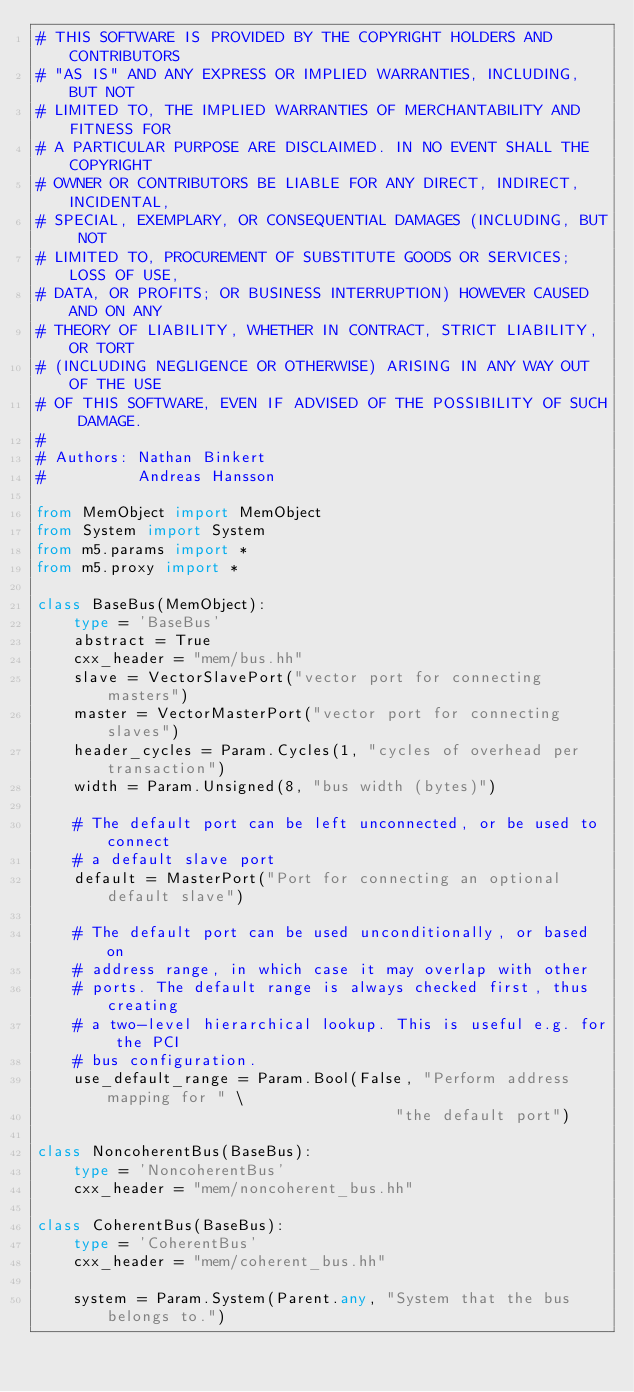Convert code to text. <code><loc_0><loc_0><loc_500><loc_500><_Python_># THIS SOFTWARE IS PROVIDED BY THE COPYRIGHT HOLDERS AND CONTRIBUTORS
# "AS IS" AND ANY EXPRESS OR IMPLIED WARRANTIES, INCLUDING, BUT NOT
# LIMITED TO, THE IMPLIED WARRANTIES OF MERCHANTABILITY AND FITNESS FOR
# A PARTICULAR PURPOSE ARE DISCLAIMED. IN NO EVENT SHALL THE COPYRIGHT
# OWNER OR CONTRIBUTORS BE LIABLE FOR ANY DIRECT, INDIRECT, INCIDENTAL,
# SPECIAL, EXEMPLARY, OR CONSEQUENTIAL DAMAGES (INCLUDING, BUT NOT
# LIMITED TO, PROCUREMENT OF SUBSTITUTE GOODS OR SERVICES; LOSS OF USE,
# DATA, OR PROFITS; OR BUSINESS INTERRUPTION) HOWEVER CAUSED AND ON ANY
# THEORY OF LIABILITY, WHETHER IN CONTRACT, STRICT LIABILITY, OR TORT
# (INCLUDING NEGLIGENCE OR OTHERWISE) ARISING IN ANY WAY OUT OF THE USE
# OF THIS SOFTWARE, EVEN IF ADVISED OF THE POSSIBILITY OF SUCH DAMAGE.
#
# Authors: Nathan Binkert
#          Andreas Hansson

from MemObject import MemObject
from System import System
from m5.params import *
from m5.proxy import *

class BaseBus(MemObject):
    type = 'BaseBus'
    abstract = True
    cxx_header = "mem/bus.hh"
    slave = VectorSlavePort("vector port for connecting masters")
    master = VectorMasterPort("vector port for connecting slaves")
    header_cycles = Param.Cycles(1, "cycles of overhead per transaction")
    width = Param.Unsigned(8, "bus width (bytes)")

    # The default port can be left unconnected, or be used to connect
    # a default slave port
    default = MasterPort("Port for connecting an optional default slave")

    # The default port can be used unconditionally, or based on
    # address range, in which case it may overlap with other
    # ports. The default range is always checked first, thus creating
    # a two-level hierarchical lookup. This is useful e.g. for the PCI
    # bus configuration.
    use_default_range = Param.Bool(False, "Perform address mapping for " \
                                       "the default port")

class NoncoherentBus(BaseBus):
    type = 'NoncoherentBus'
    cxx_header = "mem/noncoherent_bus.hh"

class CoherentBus(BaseBus):
    type = 'CoherentBus'
    cxx_header = "mem/coherent_bus.hh"

    system = Param.System(Parent.any, "System that the bus belongs to.")
</code> 